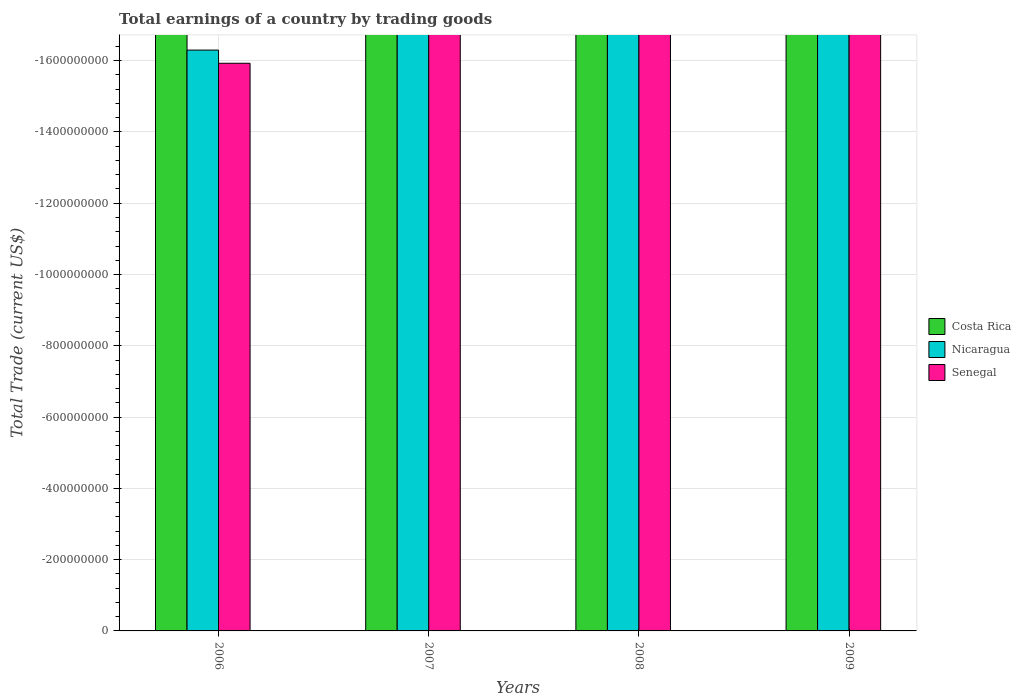Are the number of bars per tick equal to the number of legend labels?
Provide a succinct answer. No. How many bars are there on the 1st tick from the left?
Provide a succinct answer. 0. In how many cases, is the number of bars for a given year not equal to the number of legend labels?
Your answer should be very brief. 4. Across all years, what is the minimum total earnings in Nicaragua?
Offer a terse response. 0. What is the average total earnings in Senegal per year?
Your response must be concise. 0. In how many years, is the total earnings in Senegal greater than the average total earnings in Senegal taken over all years?
Your response must be concise. 0. Is it the case that in every year, the sum of the total earnings in Senegal and total earnings in Costa Rica is greater than the total earnings in Nicaragua?
Provide a succinct answer. No. How many bars are there?
Keep it short and to the point. 0. How many years are there in the graph?
Keep it short and to the point. 4. What is the difference between two consecutive major ticks on the Y-axis?
Your answer should be very brief. 2.00e+08. How many legend labels are there?
Your response must be concise. 3. How are the legend labels stacked?
Your answer should be very brief. Vertical. What is the title of the graph?
Provide a short and direct response. Total earnings of a country by trading goods. Does "European Union" appear as one of the legend labels in the graph?
Your answer should be very brief. No. What is the label or title of the Y-axis?
Your answer should be very brief. Total Trade (current US$). What is the Total Trade (current US$) in Costa Rica in 2006?
Give a very brief answer. 0. What is the Total Trade (current US$) in Senegal in 2006?
Give a very brief answer. 0. What is the Total Trade (current US$) in Nicaragua in 2007?
Keep it short and to the point. 0. What is the Total Trade (current US$) of Costa Rica in 2008?
Provide a succinct answer. 0. What is the Total Trade (current US$) in Senegal in 2008?
Keep it short and to the point. 0. What is the Total Trade (current US$) in Nicaragua in 2009?
Give a very brief answer. 0. What is the Total Trade (current US$) of Senegal in 2009?
Ensure brevity in your answer.  0. What is the total Total Trade (current US$) in Costa Rica in the graph?
Your answer should be very brief. 0. What is the average Total Trade (current US$) of Senegal per year?
Your response must be concise. 0. 